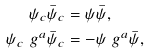<formula> <loc_0><loc_0><loc_500><loc_500>\psi _ { c } \bar { \psi } _ { c } & = \psi \bar { \psi } , \\ \psi _ { c } \ g ^ { a } \bar { \psi } _ { c } & = - \psi \ g ^ { a } \bar { \psi } ,</formula> 